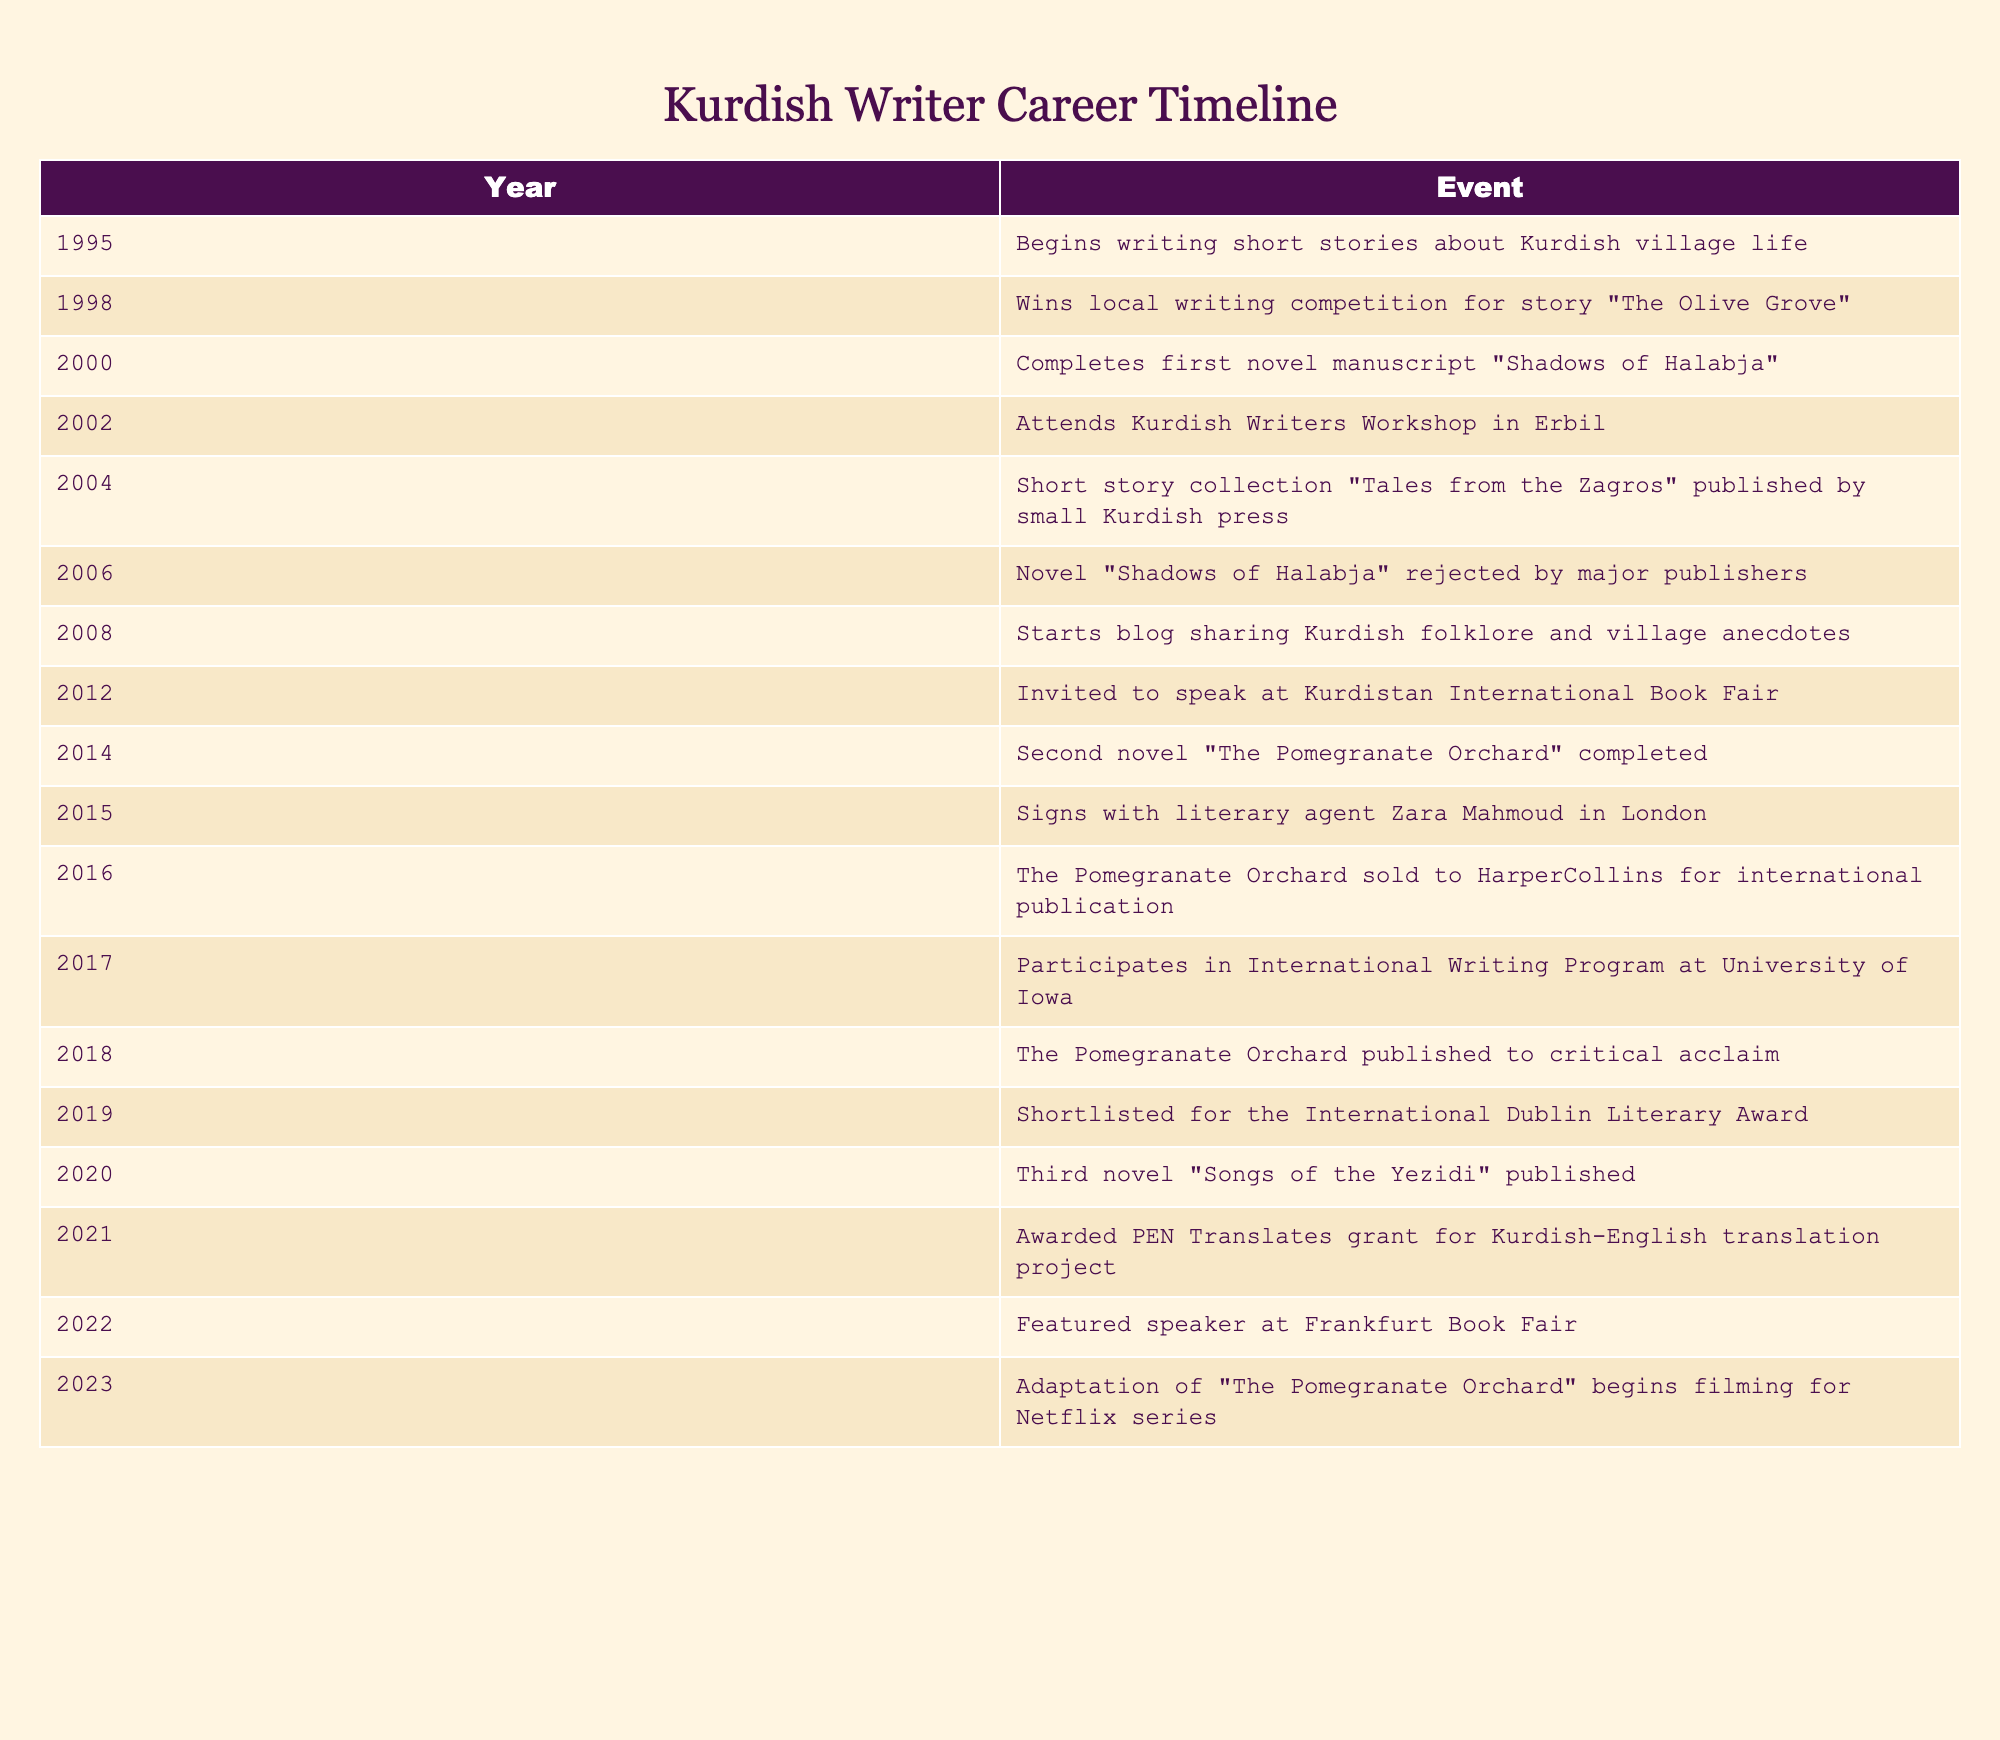What year did the writer begin writing short stories? According to the table, the writer began writing short stories about Kurdish village life in 1995.
Answer: 1995 How many years passed between completing the first novel manuscript and the publication of the short story collection? The first novel manuscript "Shadows of Halabja" was completed in 2000, and the short story collection "Tales from the Zagros" was published in 2004. The difference is 4 years (2004 - 2000).
Answer: 4 years Did the writer achieve international recognition before publishing their first novel? The table indicates that the writer had their short story collection published in 2004, and their first novel manuscript was completed in 2000. However, the significant international recognition through events like speaking at the Kurdistan International Book Fair came after 2008. Thus, the answer is no.
Answer: No How many milestones are listed in the table after the publication of "The Pomegranate Orchard"? "The Pomegranate Orchard" was published in 2018, and there are 5 milestones listed afterward: 2019 (shortlisted for award), 2020 (published third novel), 2021 (awarded grant), 2022 (featured speaker), and 2023 (filming adaptation). Therefore, the total is 5 milestones.
Answer: 5 milestones What is the significant change for the writer in 2015? In 2015, the significant event for the writer was signing with literary agent Zara Mahmoud in London, marking an important step in their career towards gaining wider recognition in the literary world.
Answer: Signing with a literary agent What was the first major event that recognized the writer’s work on an international platform? The first major event that recognized the writer's work internationally, as per the timeline, was the invitation to speak at the Kurdistan International Book Fair in 2012.
Answer: Speaking at the Kurdistan International Book Fair in 2012 What is the relationship between the completion of "The Pomegranate Orchard" and its subsequent publishing? "The Pomegranate Orchard" was completed in 2014, and it was published in 2018. This shows a 4-year period from completion to publication during which the work likely underwent editing and securing a publishing deal, illustrating the common timeline for novel publication.
Answer: 4 years between completion and publication How many events are listed between the years 2006 and 2014? The events listed in that timeframe are: the rejection of "Shadows of Halabja" in 2006, starting a blog in 2008, being invited to speak at the Kurdistan International Book Fair in 2012, and completing the second novel in 2014. There are a total of 4 events listed during this period.
Answer: 4 events 